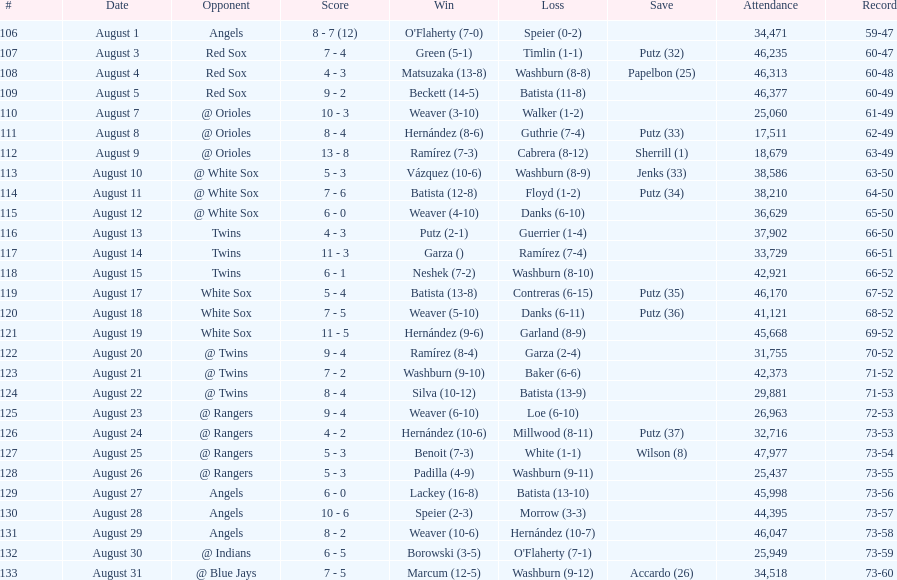Games above 30,000 in attendance 21. 